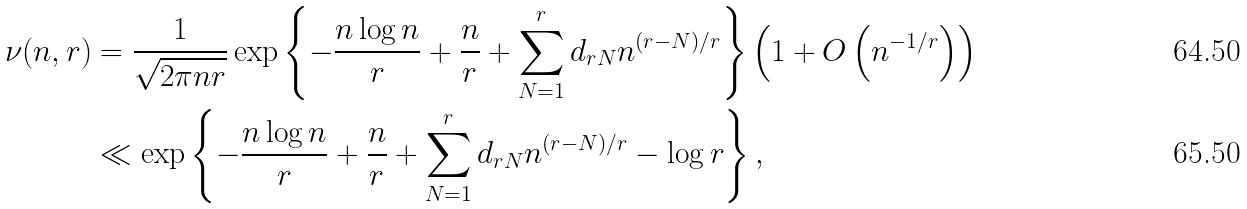<formula> <loc_0><loc_0><loc_500><loc_500>\nu ( n , r ) & = \frac { 1 } { \sqrt { 2 \pi n r } } \exp \left \{ - \frac { n \log n } { r } + \frac { n } { r } + \sum _ { N = 1 } ^ { r } d _ { r N } n ^ { ( r - N ) / r } \right \} \left ( 1 + O \left ( n ^ { - 1 / r } \right ) \right ) \\ & \ll \exp \left \{ - \frac { n \log n } { r } + \frac { n } { r } + \sum _ { N = 1 } ^ { r } d _ { r N } n ^ { ( r - N ) / r } - \log r \right \} ,</formula> 